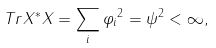Convert formula to latex. <formula><loc_0><loc_0><loc_500><loc_500>T r X ^ { * } X = \sum _ { i } \| \varphi _ { i } \| ^ { 2 } = \| \psi \| ^ { 2 } < \infty ,</formula> 